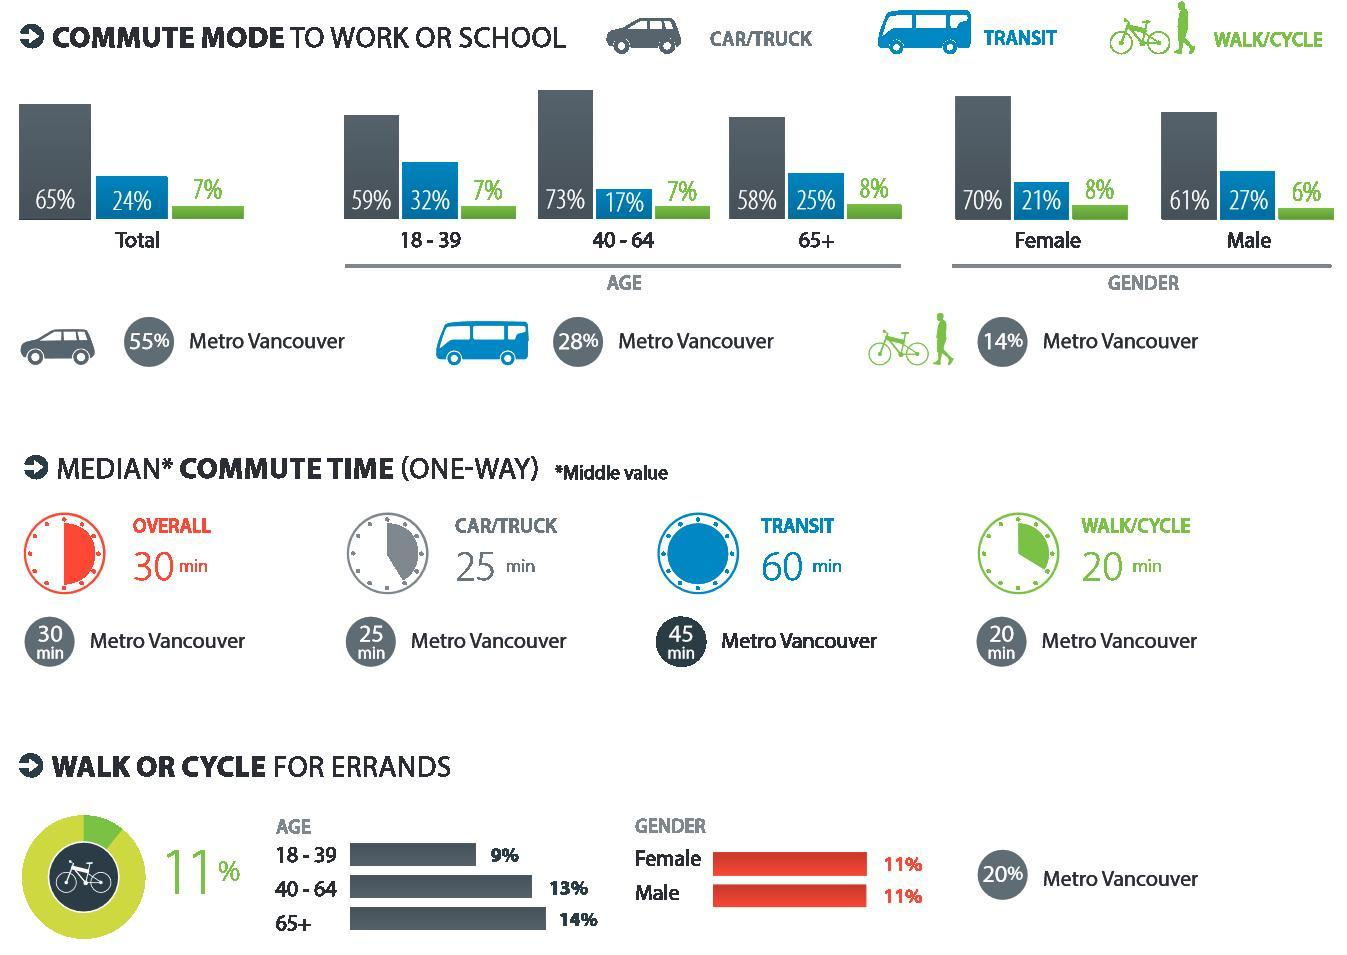what percent of people commute to work or school by TRANSIT?
Answer the question with a short phrase. 24 what percent of people commute to work or school by car/truck? 65% what percent of middle aged people commute to work or school by transit? 17% what percent of women commute to work or school by car/truck/walking/cycle? 78 what percent of senior citizens commute to work or school by walking/cycle? 8 what percent of men commute to work or school by transit/car/truck? 88% what percent of middle aged people commute to work or school by transit/walking/cycle? 24 what percent of senior citizens commute to work or school by car/truck/walking/cycle? 64 what percent of women commute to work or school by car/truck? 70% what percent of women commute to work or school by transit? 21% what percent of senior citizens commute to work or school by transit/walking/cycle? 33% what percent of people commute to work or school by walking/cycle? 7 what percent of men commute to work or school by walking/cycle? 6 what percent of middle aged people commute to work or school by car/truck? 73% what percent of men commute to work or school by transit? 27% 